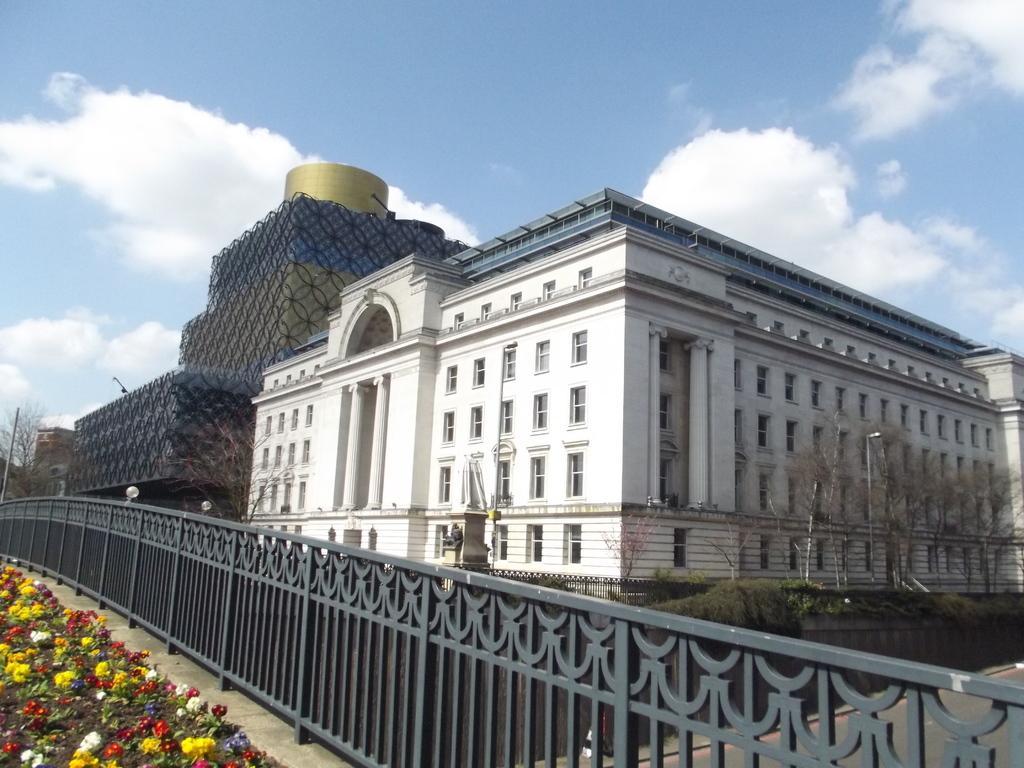Can you describe this image briefly? In the center of the image there is a building. There is a railing. There are trees. To the left side of the image there are flower plants. At the top of the image there is sky. 